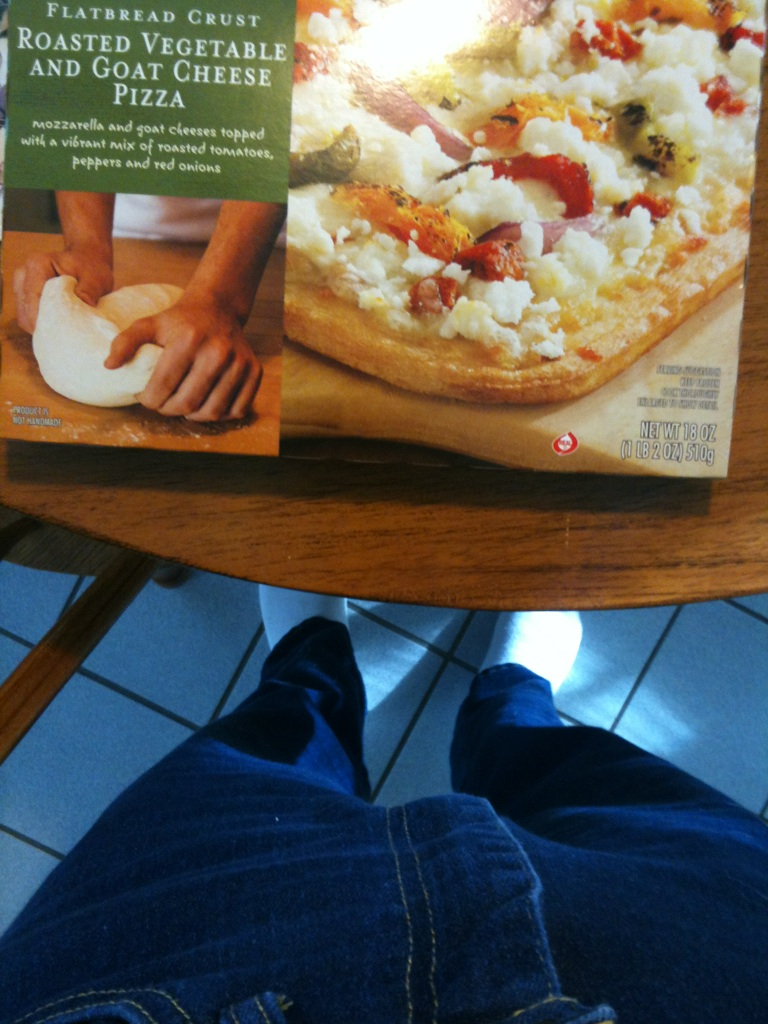What pizza is this? This is a flatbread crust pizza featuring roasted vegetables and goat cheese. It's topped with mozzarella and goat cheeses, along with a vibrant mix of roasted tomatoes, peppers, and red onions, offering a delightful medley of flavors. 